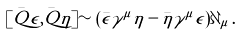<formula> <loc_0><loc_0><loc_500><loc_500>[ \bar { Q } \epsilon , \bar { Q } \eta ] \sim ( \bar { \epsilon } \gamma ^ { \mu } \eta - \bar { \eta } \gamma ^ { \mu } \epsilon ) \partial _ { \mu } \, .</formula> 